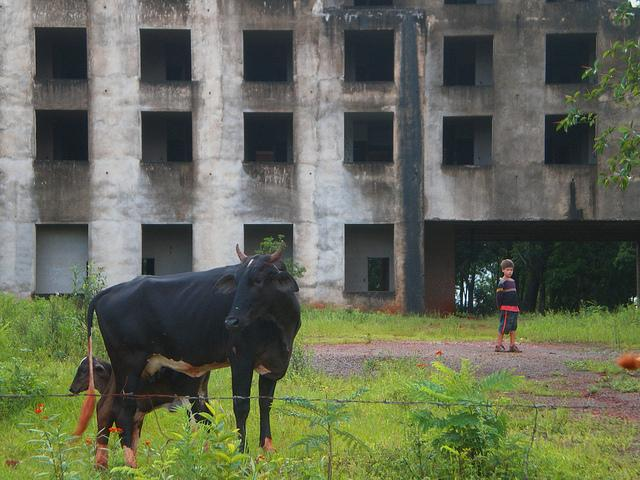What animals is the child looking at? cow 